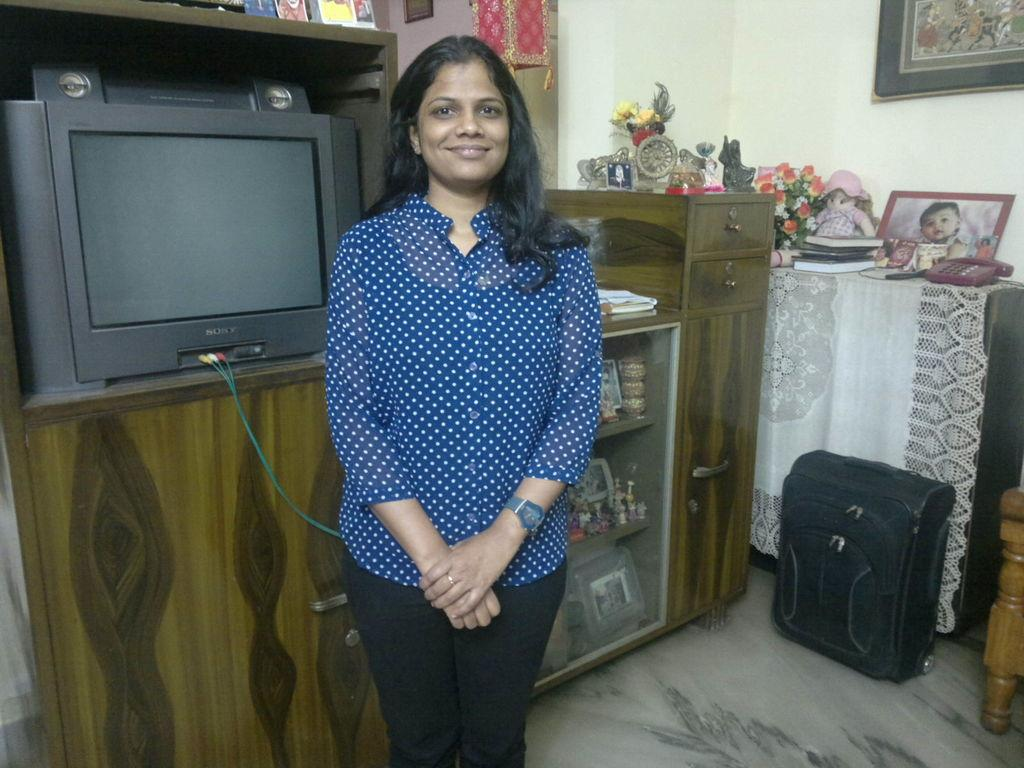What is the main subject in the image? There is a woman standing in the image. What can be seen in the background of the image? There is a table in the background of the image. What is on the table? There is a TV, books, and showpieces on the table. Where is the bag located in the image? There is a bag on the right side of the image. What else can be seen on the right side of the image? There are frames on the right side of the image. What type of rice is being cooked in the oven in the image? There is no oven or rice present in the image. 